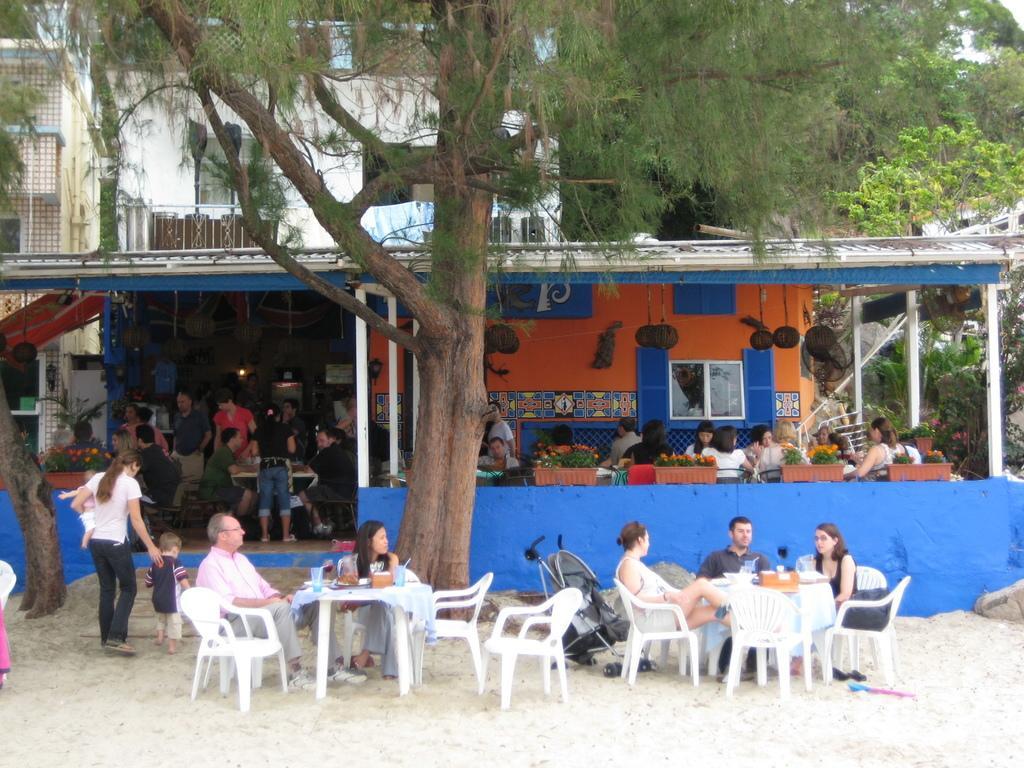In one or two sentences, can you explain what this image depicts? In this image i can see few people sitting on chairs in front of table under the tree, On the table i can see few glasses and few objects. In the background i can see a tent and few people sitting on chairs in front of tables, a tree, a store and a building. 